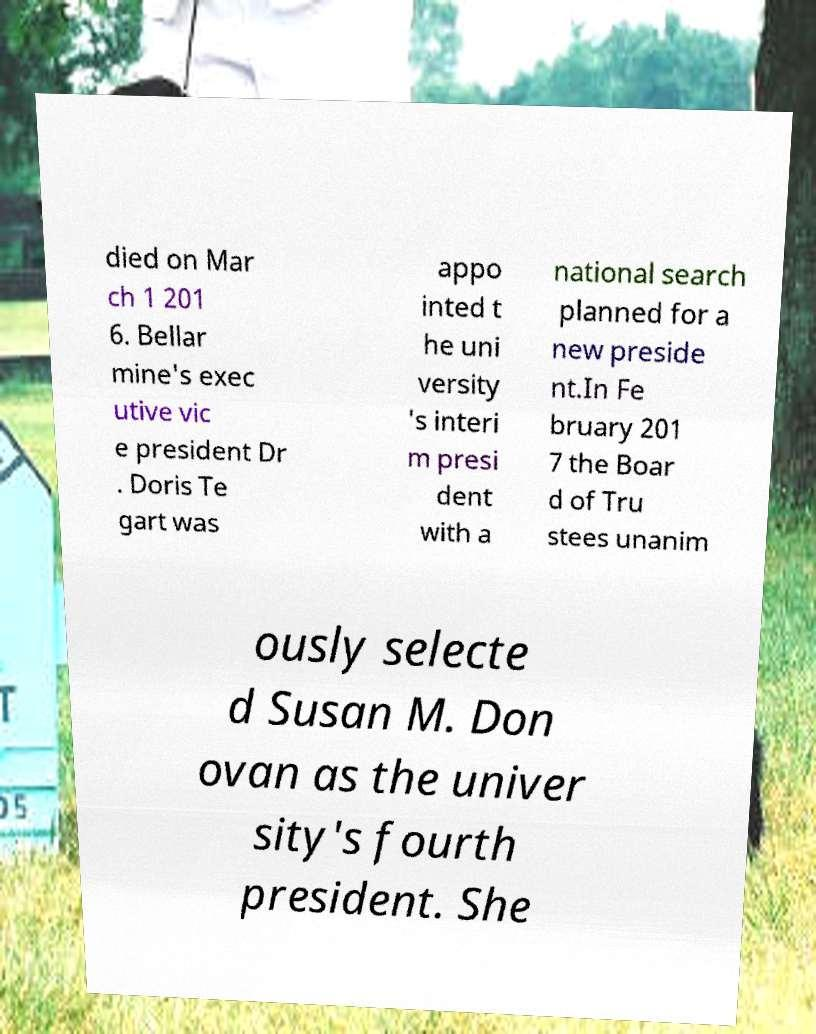Please identify and transcribe the text found in this image. died on Mar ch 1 201 6. Bellar mine's exec utive vic e president Dr . Doris Te gart was appo inted t he uni versity 's interi m presi dent with a national search planned for a new preside nt.In Fe bruary 201 7 the Boar d of Tru stees unanim ously selecte d Susan M. Don ovan as the univer sity's fourth president. She 